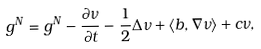<formula> <loc_0><loc_0><loc_500><loc_500>g ^ { N } = g ^ { N } - \frac { \partial \nu } { \partial t } - \frac { 1 } { 2 } \Delta \nu + \langle b , \nabla \nu \rangle + c \nu ,</formula> 